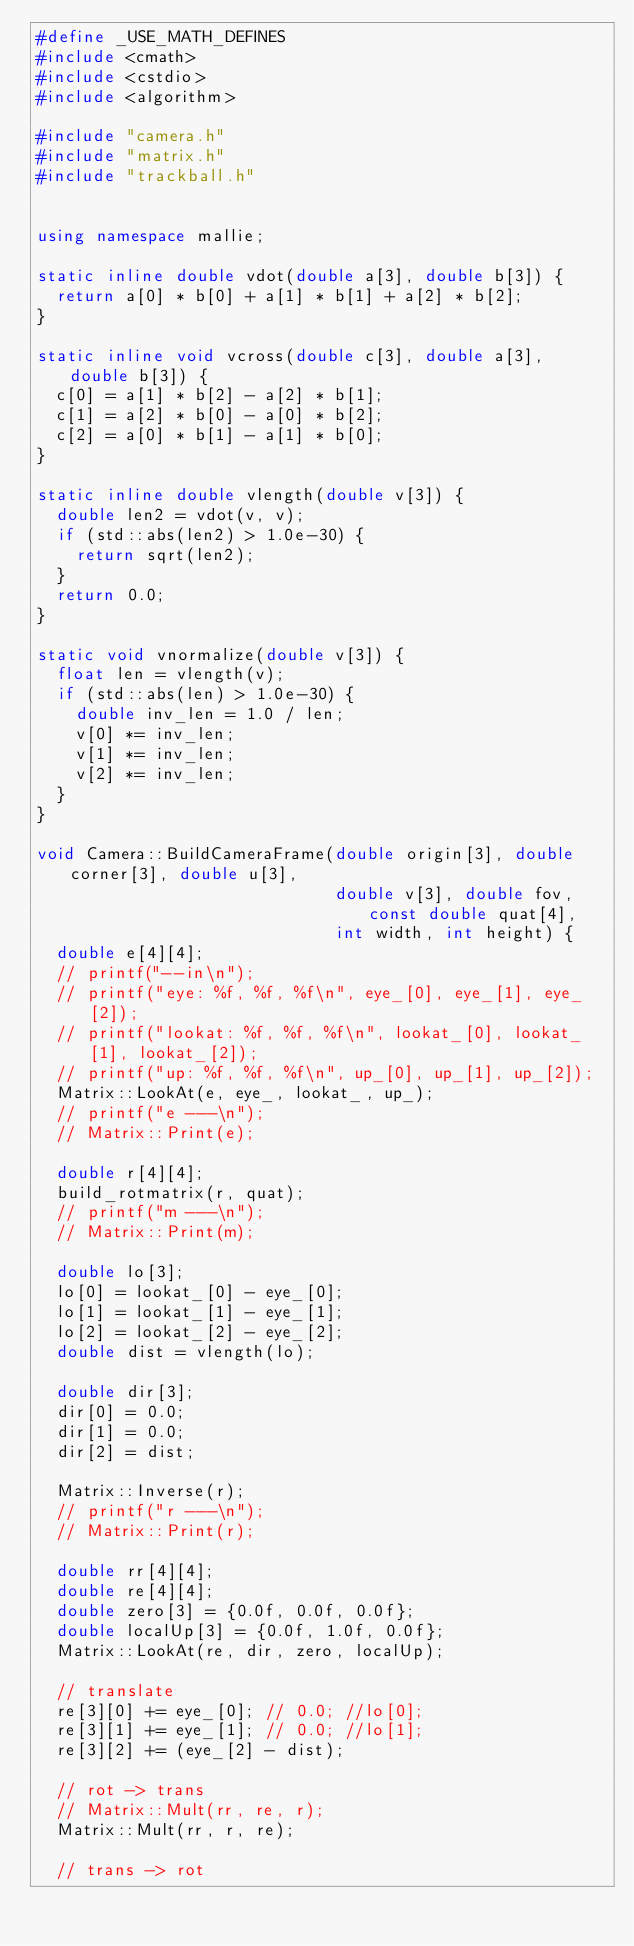Convert code to text. <code><loc_0><loc_0><loc_500><loc_500><_C++_>#define _USE_MATH_DEFINES
#include <cmath>
#include <cstdio>
#include <algorithm>

#include "camera.h"
#include "matrix.h"
#include "trackball.h"


using namespace mallie;

static inline double vdot(double a[3], double b[3]) {
  return a[0] * b[0] + a[1] * b[1] + a[2] * b[2];
}

static inline void vcross(double c[3], double a[3], double b[3]) {
  c[0] = a[1] * b[2] - a[2] * b[1];
  c[1] = a[2] * b[0] - a[0] * b[2];
  c[2] = a[0] * b[1] - a[1] * b[0];
}

static inline double vlength(double v[3]) {
  double len2 = vdot(v, v);
  if (std::abs(len2) > 1.0e-30) {
    return sqrt(len2);
  }
  return 0.0;
}

static void vnormalize(double v[3]) {
  float len = vlength(v);
  if (std::abs(len) > 1.0e-30) {
    double inv_len = 1.0 / len;
    v[0] *= inv_len;
    v[1] *= inv_len;
    v[2] *= inv_len;
  }
}

void Camera::BuildCameraFrame(double origin[3], double corner[3], double u[3],
                              double v[3], double fov, const double quat[4],
                              int width, int height) {
  double e[4][4];
  // printf("--in\n");
  // printf("eye: %f, %f, %f\n", eye_[0], eye_[1], eye_[2]);
  // printf("lookat: %f, %f, %f\n", lookat_[0], lookat_[1], lookat_[2]);
  // printf("up: %f, %f, %f\n", up_[0], up_[1], up_[2]);
  Matrix::LookAt(e, eye_, lookat_, up_);
  // printf("e ---\n");
  // Matrix::Print(e);

  double r[4][4];
  build_rotmatrix(r, quat);
  // printf("m ---\n");
  // Matrix::Print(m);

  double lo[3];
  lo[0] = lookat_[0] - eye_[0];
  lo[1] = lookat_[1] - eye_[1];
  lo[2] = lookat_[2] - eye_[2];
  double dist = vlength(lo);

  double dir[3];
  dir[0] = 0.0;
  dir[1] = 0.0;
  dir[2] = dist;

  Matrix::Inverse(r);
  // printf("r ---\n");
  // Matrix::Print(r);

  double rr[4][4];
  double re[4][4];
  double zero[3] = {0.0f, 0.0f, 0.0f};
  double localUp[3] = {0.0f, 1.0f, 0.0f};
  Matrix::LookAt(re, dir, zero, localUp);

  // translate
  re[3][0] += eye_[0]; // 0.0; //lo[0];
  re[3][1] += eye_[1]; // 0.0; //lo[1];
  re[3][2] += (eye_[2] - dist);

  // rot -> trans
  // Matrix::Mult(rr, re, r);
  Matrix::Mult(rr, r, re);

  // trans -> rot</code> 